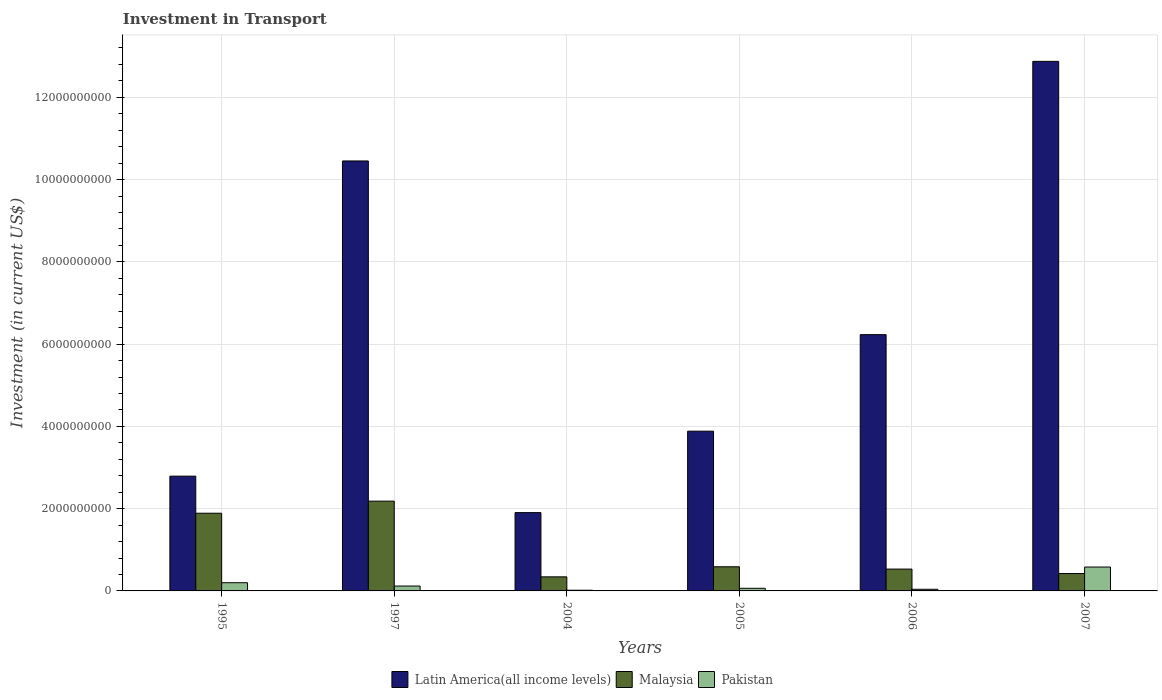Are the number of bars on each tick of the X-axis equal?
Your answer should be compact. Yes. How many bars are there on the 5th tick from the right?
Provide a short and direct response. 3. In how many cases, is the number of bars for a given year not equal to the number of legend labels?
Offer a very short reply. 0. What is the amount invested in transport in Malaysia in 1997?
Provide a succinct answer. 2.18e+09. Across all years, what is the maximum amount invested in transport in Pakistan?
Keep it short and to the point. 5.81e+08. Across all years, what is the minimum amount invested in transport in Pakistan?
Ensure brevity in your answer.  1.70e+07. What is the total amount invested in transport in Malaysia in the graph?
Offer a very short reply. 5.95e+09. What is the difference between the amount invested in transport in Malaysia in 1995 and that in 2004?
Give a very brief answer. 1.55e+09. What is the difference between the amount invested in transport in Latin America(all income levels) in 2005 and the amount invested in transport in Malaysia in 2004?
Give a very brief answer. 3.54e+09. What is the average amount invested in transport in Malaysia per year?
Make the answer very short. 9.92e+08. In the year 2004, what is the difference between the amount invested in transport in Latin America(all income levels) and amount invested in transport in Pakistan?
Ensure brevity in your answer.  1.89e+09. What is the ratio of the amount invested in transport in Latin America(all income levels) in 2005 to that in 2006?
Keep it short and to the point. 0.62. Is the amount invested in transport in Malaysia in 2004 less than that in 2005?
Your answer should be very brief. Yes. What is the difference between the highest and the second highest amount invested in transport in Malaysia?
Make the answer very short. 2.93e+08. What is the difference between the highest and the lowest amount invested in transport in Latin America(all income levels)?
Your response must be concise. 1.10e+1. In how many years, is the amount invested in transport in Pakistan greater than the average amount invested in transport in Pakistan taken over all years?
Offer a very short reply. 2. What does the 1st bar from the left in 2005 represents?
Offer a very short reply. Latin America(all income levels). What does the 3rd bar from the right in 2004 represents?
Give a very brief answer. Latin America(all income levels). How many bars are there?
Offer a terse response. 18. Are all the bars in the graph horizontal?
Offer a very short reply. No. What is the difference between two consecutive major ticks on the Y-axis?
Ensure brevity in your answer.  2.00e+09. Are the values on the major ticks of Y-axis written in scientific E-notation?
Make the answer very short. No. Does the graph contain grids?
Your answer should be compact. Yes. Where does the legend appear in the graph?
Offer a very short reply. Bottom center. How many legend labels are there?
Your response must be concise. 3. How are the legend labels stacked?
Your answer should be very brief. Horizontal. What is the title of the graph?
Provide a succinct answer. Investment in Transport. Does "Malaysia" appear as one of the legend labels in the graph?
Make the answer very short. Yes. What is the label or title of the X-axis?
Your response must be concise. Years. What is the label or title of the Y-axis?
Ensure brevity in your answer.  Investment (in current US$). What is the Investment (in current US$) of Latin America(all income levels) in 1995?
Offer a very short reply. 2.79e+09. What is the Investment (in current US$) of Malaysia in 1995?
Your answer should be very brief. 1.89e+09. What is the Investment (in current US$) of Pakistan in 1995?
Provide a short and direct response. 2.00e+08. What is the Investment (in current US$) in Latin America(all income levels) in 1997?
Provide a succinct answer. 1.05e+1. What is the Investment (in current US$) in Malaysia in 1997?
Give a very brief answer. 2.18e+09. What is the Investment (in current US$) in Pakistan in 1997?
Keep it short and to the point. 1.19e+08. What is the Investment (in current US$) of Latin America(all income levels) in 2004?
Keep it short and to the point. 1.90e+09. What is the Investment (in current US$) of Malaysia in 2004?
Offer a very short reply. 3.42e+08. What is the Investment (in current US$) in Pakistan in 2004?
Your answer should be very brief. 1.70e+07. What is the Investment (in current US$) of Latin America(all income levels) in 2005?
Your answer should be compact. 3.88e+09. What is the Investment (in current US$) of Malaysia in 2005?
Your answer should be very brief. 5.87e+08. What is the Investment (in current US$) of Pakistan in 2005?
Your answer should be very brief. 6.40e+07. What is the Investment (in current US$) in Latin America(all income levels) in 2006?
Give a very brief answer. 6.23e+09. What is the Investment (in current US$) of Malaysia in 2006?
Offer a very short reply. 5.31e+08. What is the Investment (in current US$) of Pakistan in 2006?
Keep it short and to the point. 4.00e+07. What is the Investment (in current US$) of Latin America(all income levels) in 2007?
Your answer should be compact. 1.29e+1. What is the Investment (in current US$) of Malaysia in 2007?
Offer a very short reply. 4.23e+08. What is the Investment (in current US$) in Pakistan in 2007?
Make the answer very short. 5.81e+08. Across all years, what is the maximum Investment (in current US$) in Latin America(all income levels)?
Your response must be concise. 1.29e+1. Across all years, what is the maximum Investment (in current US$) of Malaysia?
Your answer should be compact. 2.18e+09. Across all years, what is the maximum Investment (in current US$) of Pakistan?
Provide a succinct answer. 5.81e+08. Across all years, what is the minimum Investment (in current US$) of Latin America(all income levels)?
Provide a short and direct response. 1.90e+09. Across all years, what is the minimum Investment (in current US$) of Malaysia?
Your answer should be very brief. 3.42e+08. Across all years, what is the minimum Investment (in current US$) in Pakistan?
Offer a very short reply. 1.70e+07. What is the total Investment (in current US$) in Latin America(all income levels) in the graph?
Make the answer very short. 3.81e+1. What is the total Investment (in current US$) of Malaysia in the graph?
Offer a very short reply. 5.95e+09. What is the total Investment (in current US$) in Pakistan in the graph?
Provide a succinct answer. 1.02e+09. What is the difference between the Investment (in current US$) in Latin America(all income levels) in 1995 and that in 1997?
Make the answer very short. -7.66e+09. What is the difference between the Investment (in current US$) in Malaysia in 1995 and that in 1997?
Make the answer very short. -2.93e+08. What is the difference between the Investment (in current US$) of Pakistan in 1995 and that in 1997?
Offer a very short reply. 8.09e+07. What is the difference between the Investment (in current US$) of Latin America(all income levels) in 1995 and that in 2004?
Provide a short and direct response. 8.87e+08. What is the difference between the Investment (in current US$) in Malaysia in 1995 and that in 2004?
Give a very brief answer. 1.55e+09. What is the difference between the Investment (in current US$) of Pakistan in 1995 and that in 2004?
Your answer should be compact. 1.83e+08. What is the difference between the Investment (in current US$) in Latin America(all income levels) in 1995 and that in 2005?
Give a very brief answer. -1.09e+09. What is the difference between the Investment (in current US$) of Malaysia in 1995 and that in 2005?
Your response must be concise. 1.30e+09. What is the difference between the Investment (in current US$) of Pakistan in 1995 and that in 2005?
Your answer should be very brief. 1.36e+08. What is the difference between the Investment (in current US$) in Latin America(all income levels) in 1995 and that in 2006?
Make the answer very short. -3.44e+09. What is the difference between the Investment (in current US$) in Malaysia in 1995 and that in 2006?
Give a very brief answer. 1.36e+09. What is the difference between the Investment (in current US$) of Pakistan in 1995 and that in 2006?
Offer a terse response. 1.60e+08. What is the difference between the Investment (in current US$) in Latin America(all income levels) in 1995 and that in 2007?
Offer a terse response. -1.01e+1. What is the difference between the Investment (in current US$) in Malaysia in 1995 and that in 2007?
Provide a short and direct response. 1.47e+09. What is the difference between the Investment (in current US$) of Pakistan in 1995 and that in 2007?
Provide a short and direct response. -3.81e+08. What is the difference between the Investment (in current US$) in Latin America(all income levels) in 1997 and that in 2004?
Offer a terse response. 8.55e+09. What is the difference between the Investment (in current US$) of Malaysia in 1997 and that in 2004?
Make the answer very short. 1.84e+09. What is the difference between the Investment (in current US$) of Pakistan in 1997 and that in 2004?
Ensure brevity in your answer.  1.02e+08. What is the difference between the Investment (in current US$) in Latin America(all income levels) in 1997 and that in 2005?
Keep it short and to the point. 6.57e+09. What is the difference between the Investment (in current US$) of Malaysia in 1997 and that in 2005?
Ensure brevity in your answer.  1.60e+09. What is the difference between the Investment (in current US$) in Pakistan in 1997 and that in 2005?
Offer a terse response. 5.47e+07. What is the difference between the Investment (in current US$) of Latin America(all income levels) in 1997 and that in 2006?
Provide a succinct answer. 4.22e+09. What is the difference between the Investment (in current US$) in Malaysia in 1997 and that in 2006?
Your answer should be very brief. 1.65e+09. What is the difference between the Investment (in current US$) of Pakistan in 1997 and that in 2006?
Your answer should be compact. 7.87e+07. What is the difference between the Investment (in current US$) in Latin America(all income levels) in 1997 and that in 2007?
Ensure brevity in your answer.  -2.42e+09. What is the difference between the Investment (in current US$) of Malaysia in 1997 and that in 2007?
Provide a short and direct response. 1.76e+09. What is the difference between the Investment (in current US$) in Pakistan in 1997 and that in 2007?
Give a very brief answer. -4.62e+08. What is the difference between the Investment (in current US$) in Latin America(all income levels) in 2004 and that in 2005?
Keep it short and to the point. -1.98e+09. What is the difference between the Investment (in current US$) in Malaysia in 2004 and that in 2005?
Your answer should be very brief. -2.45e+08. What is the difference between the Investment (in current US$) of Pakistan in 2004 and that in 2005?
Provide a succinct answer. -4.70e+07. What is the difference between the Investment (in current US$) in Latin America(all income levels) in 2004 and that in 2006?
Give a very brief answer. -4.33e+09. What is the difference between the Investment (in current US$) of Malaysia in 2004 and that in 2006?
Make the answer very short. -1.89e+08. What is the difference between the Investment (in current US$) of Pakistan in 2004 and that in 2006?
Ensure brevity in your answer.  -2.30e+07. What is the difference between the Investment (in current US$) in Latin America(all income levels) in 2004 and that in 2007?
Your response must be concise. -1.10e+1. What is the difference between the Investment (in current US$) in Malaysia in 2004 and that in 2007?
Keep it short and to the point. -8.09e+07. What is the difference between the Investment (in current US$) of Pakistan in 2004 and that in 2007?
Offer a terse response. -5.64e+08. What is the difference between the Investment (in current US$) of Latin America(all income levels) in 2005 and that in 2006?
Offer a very short reply. -2.35e+09. What is the difference between the Investment (in current US$) in Malaysia in 2005 and that in 2006?
Provide a short and direct response. 5.60e+07. What is the difference between the Investment (in current US$) of Pakistan in 2005 and that in 2006?
Keep it short and to the point. 2.40e+07. What is the difference between the Investment (in current US$) in Latin America(all income levels) in 2005 and that in 2007?
Provide a succinct answer. -8.99e+09. What is the difference between the Investment (in current US$) in Malaysia in 2005 and that in 2007?
Give a very brief answer. 1.64e+08. What is the difference between the Investment (in current US$) of Pakistan in 2005 and that in 2007?
Give a very brief answer. -5.17e+08. What is the difference between the Investment (in current US$) in Latin America(all income levels) in 2006 and that in 2007?
Offer a very short reply. -6.64e+09. What is the difference between the Investment (in current US$) in Malaysia in 2006 and that in 2007?
Your answer should be compact. 1.08e+08. What is the difference between the Investment (in current US$) in Pakistan in 2006 and that in 2007?
Make the answer very short. -5.41e+08. What is the difference between the Investment (in current US$) of Latin America(all income levels) in 1995 and the Investment (in current US$) of Malaysia in 1997?
Your answer should be compact. 6.08e+08. What is the difference between the Investment (in current US$) of Latin America(all income levels) in 1995 and the Investment (in current US$) of Pakistan in 1997?
Keep it short and to the point. 2.67e+09. What is the difference between the Investment (in current US$) in Malaysia in 1995 and the Investment (in current US$) in Pakistan in 1997?
Provide a short and direct response. 1.77e+09. What is the difference between the Investment (in current US$) in Latin America(all income levels) in 1995 and the Investment (in current US$) in Malaysia in 2004?
Make the answer very short. 2.45e+09. What is the difference between the Investment (in current US$) of Latin America(all income levels) in 1995 and the Investment (in current US$) of Pakistan in 2004?
Provide a succinct answer. 2.77e+09. What is the difference between the Investment (in current US$) of Malaysia in 1995 and the Investment (in current US$) of Pakistan in 2004?
Offer a terse response. 1.87e+09. What is the difference between the Investment (in current US$) of Latin America(all income levels) in 1995 and the Investment (in current US$) of Malaysia in 2005?
Provide a short and direct response. 2.20e+09. What is the difference between the Investment (in current US$) of Latin America(all income levels) in 1995 and the Investment (in current US$) of Pakistan in 2005?
Offer a terse response. 2.73e+09. What is the difference between the Investment (in current US$) of Malaysia in 1995 and the Investment (in current US$) of Pakistan in 2005?
Keep it short and to the point. 1.82e+09. What is the difference between the Investment (in current US$) in Latin America(all income levels) in 1995 and the Investment (in current US$) in Malaysia in 2006?
Your answer should be compact. 2.26e+09. What is the difference between the Investment (in current US$) of Latin America(all income levels) in 1995 and the Investment (in current US$) of Pakistan in 2006?
Your answer should be compact. 2.75e+09. What is the difference between the Investment (in current US$) of Malaysia in 1995 and the Investment (in current US$) of Pakistan in 2006?
Your answer should be compact. 1.85e+09. What is the difference between the Investment (in current US$) in Latin America(all income levels) in 1995 and the Investment (in current US$) in Malaysia in 2007?
Provide a short and direct response. 2.37e+09. What is the difference between the Investment (in current US$) of Latin America(all income levels) in 1995 and the Investment (in current US$) of Pakistan in 2007?
Ensure brevity in your answer.  2.21e+09. What is the difference between the Investment (in current US$) of Malaysia in 1995 and the Investment (in current US$) of Pakistan in 2007?
Offer a very short reply. 1.31e+09. What is the difference between the Investment (in current US$) in Latin America(all income levels) in 1997 and the Investment (in current US$) in Malaysia in 2004?
Offer a terse response. 1.01e+1. What is the difference between the Investment (in current US$) of Latin America(all income levels) in 1997 and the Investment (in current US$) of Pakistan in 2004?
Your response must be concise. 1.04e+1. What is the difference between the Investment (in current US$) of Malaysia in 1997 and the Investment (in current US$) of Pakistan in 2004?
Give a very brief answer. 2.17e+09. What is the difference between the Investment (in current US$) in Latin America(all income levels) in 1997 and the Investment (in current US$) in Malaysia in 2005?
Your response must be concise. 9.87e+09. What is the difference between the Investment (in current US$) in Latin America(all income levels) in 1997 and the Investment (in current US$) in Pakistan in 2005?
Your response must be concise. 1.04e+1. What is the difference between the Investment (in current US$) of Malaysia in 1997 and the Investment (in current US$) of Pakistan in 2005?
Offer a very short reply. 2.12e+09. What is the difference between the Investment (in current US$) of Latin America(all income levels) in 1997 and the Investment (in current US$) of Malaysia in 2006?
Provide a short and direct response. 9.92e+09. What is the difference between the Investment (in current US$) in Latin America(all income levels) in 1997 and the Investment (in current US$) in Pakistan in 2006?
Offer a terse response. 1.04e+1. What is the difference between the Investment (in current US$) of Malaysia in 1997 and the Investment (in current US$) of Pakistan in 2006?
Provide a succinct answer. 2.14e+09. What is the difference between the Investment (in current US$) in Latin America(all income levels) in 1997 and the Investment (in current US$) in Malaysia in 2007?
Provide a succinct answer. 1.00e+1. What is the difference between the Investment (in current US$) in Latin America(all income levels) in 1997 and the Investment (in current US$) in Pakistan in 2007?
Provide a short and direct response. 9.87e+09. What is the difference between the Investment (in current US$) in Malaysia in 1997 and the Investment (in current US$) in Pakistan in 2007?
Make the answer very short. 1.60e+09. What is the difference between the Investment (in current US$) of Latin America(all income levels) in 2004 and the Investment (in current US$) of Malaysia in 2005?
Your answer should be compact. 1.32e+09. What is the difference between the Investment (in current US$) of Latin America(all income levels) in 2004 and the Investment (in current US$) of Pakistan in 2005?
Offer a very short reply. 1.84e+09. What is the difference between the Investment (in current US$) in Malaysia in 2004 and the Investment (in current US$) in Pakistan in 2005?
Make the answer very short. 2.78e+08. What is the difference between the Investment (in current US$) in Latin America(all income levels) in 2004 and the Investment (in current US$) in Malaysia in 2006?
Your answer should be very brief. 1.37e+09. What is the difference between the Investment (in current US$) of Latin America(all income levels) in 2004 and the Investment (in current US$) of Pakistan in 2006?
Your answer should be compact. 1.86e+09. What is the difference between the Investment (in current US$) in Malaysia in 2004 and the Investment (in current US$) in Pakistan in 2006?
Provide a succinct answer. 3.02e+08. What is the difference between the Investment (in current US$) of Latin America(all income levels) in 2004 and the Investment (in current US$) of Malaysia in 2007?
Give a very brief answer. 1.48e+09. What is the difference between the Investment (in current US$) in Latin America(all income levels) in 2004 and the Investment (in current US$) in Pakistan in 2007?
Keep it short and to the point. 1.32e+09. What is the difference between the Investment (in current US$) of Malaysia in 2004 and the Investment (in current US$) of Pakistan in 2007?
Offer a very short reply. -2.39e+08. What is the difference between the Investment (in current US$) of Latin America(all income levels) in 2005 and the Investment (in current US$) of Malaysia in 2006?
Offer a very short reply. 3.35e+09. What is the difference between the Investment (in current US$) of Latin America(all income levels) in 2005 and the Investment (in current US$) of Pakistan in 2006?
Your answer should be compact. 3.84e+09. What is the difference between the Investment (in current US$) in Malaysia in 2005 and the Investment (in current US$) in Pakistan in 2006?
Offer a terse response. 5.47e+08. What is the difference between the Investment (in current US$) in Latin America(all income levels) in 2005 and the Investment (in current US$) in Malaysia in 2007?
Your answer should be very brief. 3.46e+09. What is the difference between the Investment (in current US$) of Latin America(all income levels) in 2005 and the Investment (in current US$) of Pakistan in 2007?
Make the answer very short. 3.30e+09. What is the difference between the Investment (in current US$) of Malaysia in 2005 and the Investment (in current US$) of Pakistan in 2007?
Your answer should be very brief. 6.25e+06. What is the difference between the Investment (in current US$) of Latin America(all income levels) in 2006 and the Investment (in current US$) of Malaysia in 2007?
Make the answer very short. 5.81e+09. What is the difference between the Investment (in current US$) in Latin America(all income levels) in 2006 and the Investment (in current US$) in Pakistan in 2007?
Provide a short and direct response. 5.65e+09. What is the difference between the Investment (in current US$) of Malaysia in 2006 and the Investment (in current US$) of Pakistan in 2007?
Provide a short and direct response. -4.97e+07. What is the average Investment (in current US$) of Latin America(all income levels) per year?
Provide a short and direct response. 6.36e+09. What is the average Investment (in current US$) in Malaysia per year?
Your response must be concise. 9.92e+08. What is the average Investment (in current US$) of Pakistan per year?
Keep it short and to the point. 1.70e+08. In the year 1995, what is the difference between the Investment (in current US$) of Latin America(all income levels) and Investment (in current US$) of Malaysia?
Make the answer very short. 9.01e+08. In the year 1995, what is the difference between the Investment (in current US$) in Latin America(all income levels) and Investment (in current US$) in Pakistan?
Give a very brief answer. 2.59e+09. In the year 1995, what is the difference between the Investment (in current US$) of Malaysia and Investment (in current US$) of Pakistan?
Give a very brief answer. 1.69e+09. In the year 1997, what is the difference between the Investment (in current US$) of Latin America(all income levels) and Investment (in current US$) of Malaysia?
Provide a succinct answer. 8.27e+09. In the year 1997, what is the difference between the Investment (in current US$) of Latin America(all income levels) and Investment (in current US$) of Pakistan?
Offer a very short reply. 1.03e+1. In the year 1997, what is the difference between the Investment (in current US$) of Malaysia and Investment (in current US$) of Pakistan?
Your answer should be compact. 2.06e+09. In the year 2004, what is the difference between the Investment (in current US$) in Latin America(all income levels) and Investment (in current US$) in Malaysia?
Your response must be concise. 1.56e+09. In the year 2004, what is the difference between the Investment (in current US$) of Latin America(all income levels) and Investment (in current US$) of Pakistan?
Provide a short and direct response. 1.89e+09. In the year 2004, what is the difference between the Investment (in current US$) in Malaysia and Investment (in current US$) in Pakistan?
Your response must be concise. 3.25e+08. In the year 2005, what is the difference between the Investment (in current US$) of Latin America(all income levels) and Investment (in current US$) of Malaysia?
Your answer should be very brief. 3.30e+09. In the year 2005, what is the difference between the Investment (in current US$) in Latin America(all income levels) and Investment (in current US$) in Pakistan?
Provide a short and direct response. 3.82e+09. In the year 2005, what is the difference between the Investment (in current US$) in Malaysia and Investment (in current US$) in Pakistan?
Provide a short and direct response. 5.23e+08. In the year 2006, what is the difference between the Investment (in current US$) in Latin America(all income levels) and Investment (in current US$) in Malaysia?
Your answer should be compact. 5.70e+09. In the year 2006, what is the difference between the Investment (in current US$) in Latin America(all income levels) and Investment (in current US$) in Pakistan?
Give a very brief answer. 6.19e+09. In the year 2006, what is the difference between the Investment (in current US$) in Malaysia and Investment (in current US$) in Pakistan?
Offer a very short reply. 4.91e+08. In the year 2007, what is the difference between the Investment (in current US$) of Latin America(all income levels) and Investment (in current US$) of Malaysia?
Your response must be concise. 1.25e+1. In the year 2007, what is the difference between the Investment (in current US$) in Latin America(all income levels) and Investment (in current US$) in Pakistan?
Keep it short and to the point. 1.23e+1. In the year 2007, what is the difference between the Investment (in current US$) of Malaysia and Investment (in current US$) of Pakistan?
Provide a succinct answer. -1.58e+08. What is the ratio of the Investment (in current US$) of Latin America(all income levels) in 1995 to that in 1997?
Your response must be concise. 0.27. What is the ratio of the Investment (in current US$) in Malaysia in 1995 to that in 1997?
Provide a short and direct response. 0.87. What is the ratio of the Investment (in current US$) in Pakistan in 1995 to that in 1997?
Your response must be concise. 1.68. What is the ratio of the Investment (in current US$) in Latin America(all income levels) in 1995 to that in 2004?
Provide a short and direct response. 1.47. What is the ratio of the Investment (in current US$) of Malaysia in 1995 to that in 2004?
Your answer should be compact. 5.52. What is the ratio of the Investment (in current US$) in Pakistan in 1995 to that in 2004?
Offer a very short reply. 11.74. What is the ratio of the Investment (in current US$) in Latin America(all income levels) in 1995 to that in 2005?
Offer a very short reply. 0.72. What is the ratio of the Investment (in current US$) in Malaysia in 1995 to that in 2005?
Your response must be concise. 3.22. What is the ratio of the Investment (in current US$) of Pakistan in 1995 to that in 2005?
Your response must be concise. 3.12. What is the ratio of the Investment (in current US$) of Latin America(all income levels) in 1995 to that in 2006?
Offer a very short reply. 0.45. What is the ratio of the Investment (in current US$) of Malaysia in 1995 to that in 2006?
Your answer should be compact. 3.56. What is the ratio of the Investment (in current US$) of Pakistan in 1995 to that in 2006?
Make the answer very short. 4.99. What is the ratio of the Investment (in current US$) of Latin America(all income levels) in 1995 to that in 2007?
Offer a terse response. 0.22. What is the ratio of the Investment (in current US$) of Malaysia in 1995 to that in 2007?
Your response must be concise. 4.47. What is the ratio of the Investment (in current US$) of Pakistan in 1995 to that in 2007?
Your response must be concise. 0.34. What is the ratio of the Investment (in current US$) of Latin America(all income levels) in 1997 to that in 2004?
Your response must be concise. 5.49. What is the ratio of the Investment (in current US$) of Malaysia in 1997 to that in 2004?
Offer a terse response. 6.38. What is the ratio of the Investment (in current US$) in Pakistan in 1997 to that in 2004?
Your response must be concise. 6.98. What is the ratio of the Investment (in current US$) in Latin America(all income levels) in 1997 to that in 2005?
Give a very brief answer. 2.69. What is the ratio of the Investment (in current US$) in Malaysia in 1997 to that in 2005?
Your response must be concise. 3.72. What is the ratio of the Investment (in current US$) of Pakistan in 1997 to that in 2005?
Offer a very short reply. 1.85. What is the ratio of the Investment (in current US$) of Latin America(all income levels) in 1997 to that in 2006?
Make the answer very short. 1.68. What is the ratio of the Investment (in current US$) of Malaysia in 1997 to that in 2006?
Your response must be concise. 4.11. What is the ratio of the Investment (in current US$) in Pakistan in 1997 to that in 2006?
Give a very brief answer. 2.97. What is the ratio of the Investment (in current US$) in Latin America(all income levels) in 1997 to that in 2007?
Offer a very short reply. 0.81. What is the ratio of the Investment (in current US$) in Malaysia in 1997 to that in 2007?
Provide a short and direct response. 5.16. What is the ratio of the Investment (in current US$) in Pakistan in 1997 to that in 2007?
Ensure brevity in your answer.  0.2. What is the ratio of the Investment (in current US$) in Latin America(all income levels) in 2004 to that in 2005?
Ensure brevity in your answer.  0.49. What is the ratio of the Investment (in current US$) in Malaysia in 2004 to that in 2005?
Keep it short and to the point. 0.58. What is the ratio of the Investment (in current US$) in Pakistan in 2004 to that in 2005?
Give a very brief answer. 0.27. What is the ratio of the Investment (in current US$) of Latin America(all income levels) in 2004 to that in 2006?
Offer a terse response. 0.31. What is the ratio of the Investment (in current US$) in Malaysia in 2004 to that in 2006?
Ensure brevity in your answer.  0.64. What is the ratio of the Investment (in current US$) in Pakistan in 2004 to that in 2006?
Ensure brevity in your answer.  0.42. What is the ratio of the Investment (in current US$) in Latin America(all income levels) in 2004 to that in 2007?
Provide a succinct answer. 0.15. What is the ratio of the Investment (in current US$) of Malaysia in 2004 to that in 2007?
Keep it short and to the point. 0.81. What is the ratio of the Investment (in current US$) of Pakistan in 2004 to that in 2007?
Offer a terse response. 0.03. What is the ratio of the Investment (in current US$) in Latin America(all income levels) in 2005 to that in 2006?
Give a very brief answer. 0.62. What is the ratio of the Investment (in current US$) in Malaysia in 2005 to that in 2006?
Provide a short and direct response. 1.11. What is the ratio of the Investment (in current US$) in Pakistan in 2005 to that in 2006?
Offer a terse response. 1.6. What is the ratio of the Investment (in current US$) of Latin America(all income levels) in 2005 to that in 2007?
Keep it short and to the point. 0.3. What is the ratio of the Investment (in current US$) of Malaysia in 2005 to that in 2007?
Make the answer very short. 1.39. What is the ratio of the Investment (in current US$) of Pakistan in 2005 to that in 2007?
Your answer should be compact. 0.11. What is the ratio of the Investment (in current US$) of Latin America(all income levels) in 2006 to that in 2007?
Provide a short and direct response. 0.48. What is the ratio of the Investment (in current US$) in Malaysia in 2006 to that in 2007?
Your response must be concise. 1.26. What is the ratio of the Investment (in current US$) of Pakistan in 2006 to that in 2007?
Your answer should be very brief. 0.07. What is the difference between the highest and the second highest Investment (in current US$) in Latin America(all income levels)?
Your response must be concise. 2.42e+09. What is the difference between the highest and the second highest Investment (in current US$) in Malaysia?
Your answer should be compact. 2.93e+08. What is the difference between the highest and the second highest Investment (in current US$) in Pakistan?
Offer a very short reply. 3.81e+08. What is the difference between the highest and the lowest Investment (in current US$) of Latin America(all income levels)?
Provide a succinct answer. 1.10e+1. What is the difference between the highest and the lowest Investment (in current US$) in Malaysia?
Offer a very short reply. 1.84e+09. What is the difference between the highest and the lowest Investment (in current US$) in Pakistan?
Your answer should be compact. 5.64e+08. 